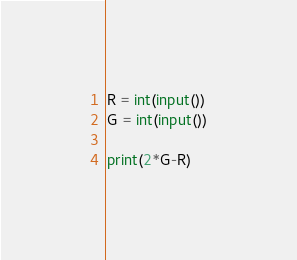<code> <loc_0><loc_0><loc_500><loc_500><_Python_>R = int(input())
G = int(input())

print(2*G-R)</code> 